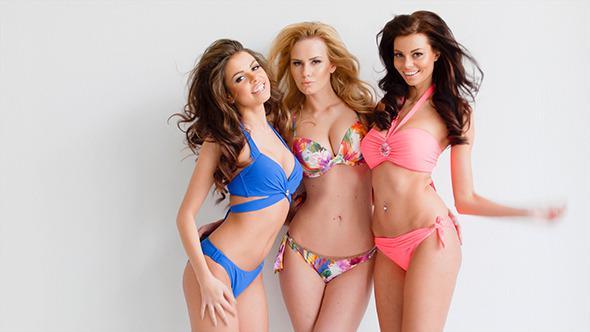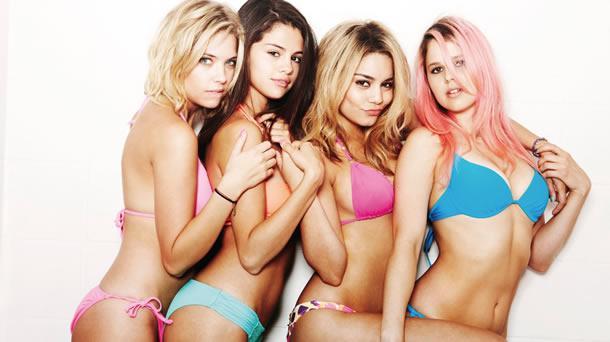The first image is the image on the left, the second image is the image on the right. Given the left and right images, does the statement "One image shows a trio of bikini models with backs to the camera and arms around each other." hold true? Answer yes or no. No. The first image is the image on the left, the second image is the image on the right. Assess this claim about the two images: "One woman poses in a bikini in one image, while three women pose in the other image.". Correct or not? Answer yes or no. No. 